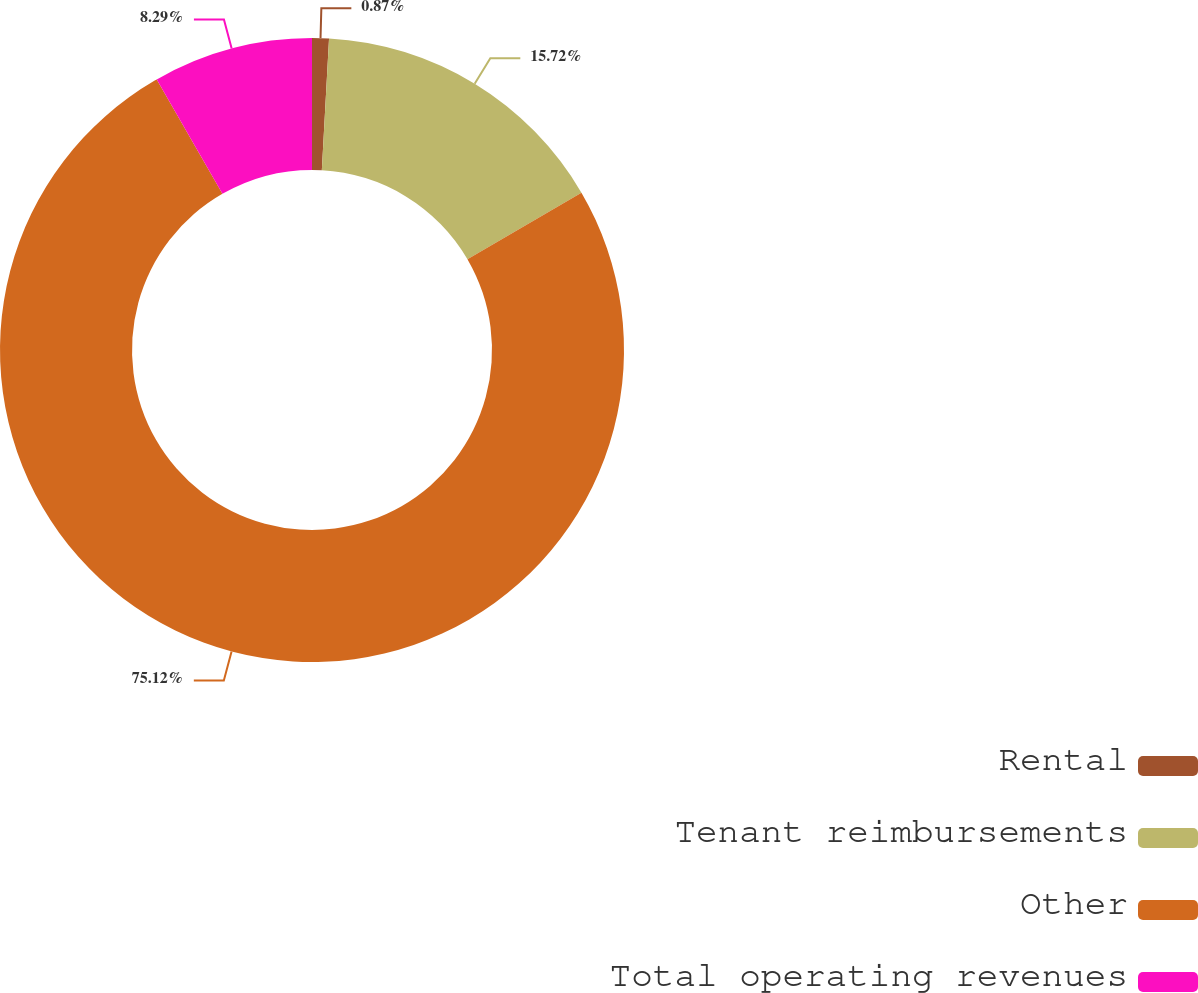<chart> <loc_0><loc_0><loc_500><loc_500><pie_chart><fcel>Rental<fcel>Tenant reimbursements<fcel>Other<fcel>Total operating revenues<nl><fcel>0.87%<fcel>15.72%<fcel>75.12%<fcel>8.29%<nl></chart> 